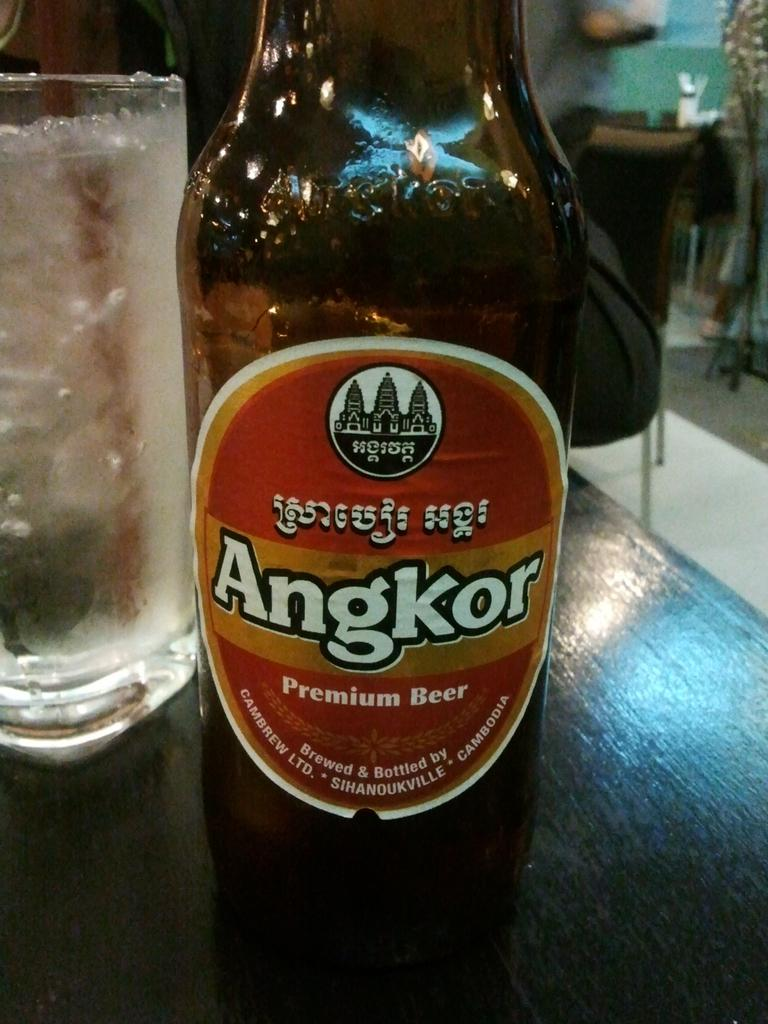Provide a one-sentence caption for the provided image. A bottle of Angkor Premium Beer sits on a wooden table. 